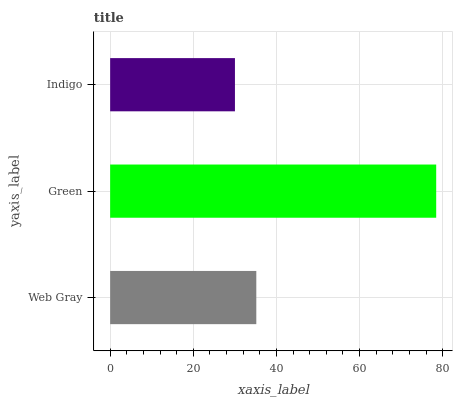Is Indigo the minimum?
Answer yes or no. Yes. Is Green the maximum?
Answer yes or no. Yes. Is Green the minimum?
Answer yes or no. No. Is Indigo the maximum?
Answer yes or no. No. Is Green greater than Indigo?
Answer yes or no. Yes. Is Indigo less than Green?
Answer yes or no. Yes. Is Indigo greater than Green?
Answer yes or no. No. Is Green less than Indigo?
Answer yes or no. No. Is Web Gray the high median?
Answer yes or no. Yes. Is Web Gray the low median?
Answer yes or no. Yes. Is Green the high median?
Answer yes or no. No. Is Indigo the low median?
Answer yes or no. No. 